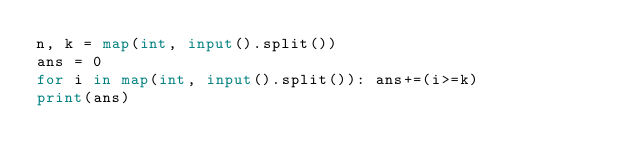<code> <loc_0><loc_0><loc_500><loc_500><_Python_>n, k = map(int, input().split())
ans = 0
for i in map(int, input().split()): ans+=(i>=k)
print(ans)</code> 